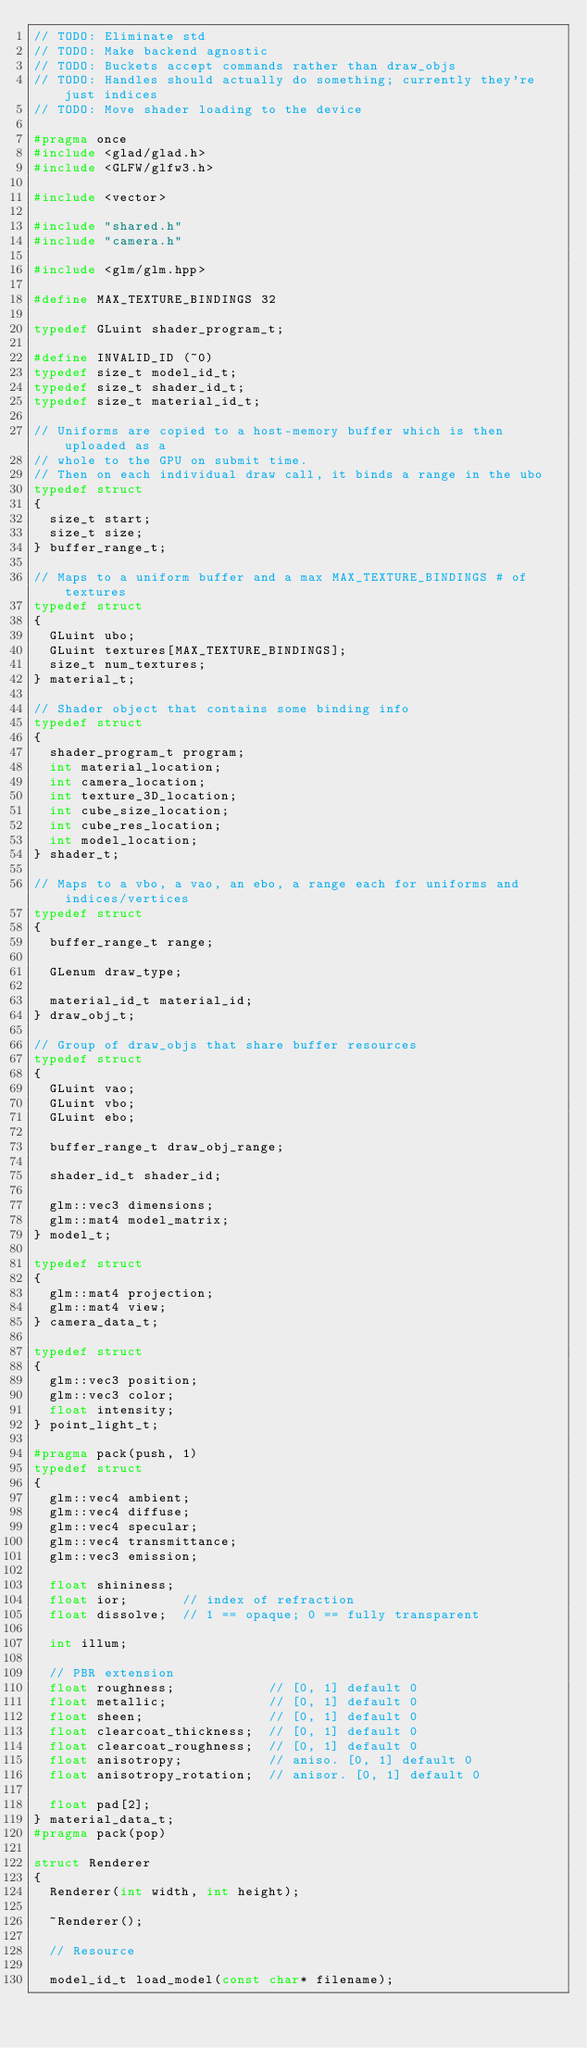Convert code to text. <code><loc_0><loc_0><loc_500><loc_500><_C_>// TODO: Eliminate std
// TODO: Make backend agnostic
// TODO: Buckets accept commands rather than draw_objs
// TODO: Handles should actually do something; currently they're just indices
// TODO: Move shader loading to the device

#pragma once
#include <glad/glad.h>
#include <GLFW/glfw3.h>

#include <vector>

#include "shared.h"
#include "camera.h"

#include <glm/glm.hpp>

#define MAX_TEXTURE_BINDINGS 32

typedef GLuint shader_program_t;

#define INVALID_ID (~0)
typedef size_t model_id_t;
typedef size_t shader_id_t;
typedef size_t material_id_t;

// Uniforms are copied to a host-memory buffer which is then uploaded as a
// whole to the GPU on submit time.
// Then on each individual draw call, it binds a range in the ubo
typedef struct
{
  size_t start;
  size_t size;  
} buffer_range_t;

// Maps to a uniform buffer and a max MAX_TEXTURE_BINDINGS # of textures
typedef struct
{
  GLuint ubo;
  GLuint textures[MAX_TEXTURE_BINDINGS];
  size_t num_textures;
} material_t;

// Shader object that contains some binding info 
typedef struct
{
  shader_program_t program;
  int material_location;
  int camera_location;
  int texture_3D_location;
  int cube_size_location;
  int cube_res_location;
  int model_location;
} shader_t;

// Maps to a vbo, a vao, an ebo, a range each for uniforms and indices/vertices
typedef struct
{
  buffer_range_t range;
  
  GLenum draw_type;
  
  material_id_t material_id;
} draw_obj_t;

// Group of draw_objs that share buffer resources
typedef struct
{
  GLuint vao;
  GLuint vbo;
  GLuint ebo;

  buffer_range_t draw_obj_range;

  shader_id_t shader_id;

  glm::vec3 dimensions;
  glm::mat4 model_matrix;
} model_t;

typedef struct
{
  glm::mat4 projection;
  glm::mat4 view;
} camera_data_t;

typedef struct
{
  glm::vec3 position;
  glm::vec3 color;
  float intensity;
} point_light_t;

#pragma pack(push, 1)
typedef struct 
{
  glm::vec4 ambient;
  glm::vec4 diffuse;
  glm::vec4 specular;
  glm::vec4 transmittance;
  glm::vec3 emission;

  float shininess;
  float ior;       // index of refraction
  float dissolve;  // 1 == opaque; 0 == fully transparent

  int illum;

  // PBR extension
  float roughness;            // [0, 1] default 0
  float metallic;             // [0, 1] default 0
  float sheen;                // [0, 1] default 0
  float clearcoat_thickness;  // [0, 1] default 0
  float clearcoat_roughness;  // [0, 1] default 0
  float anisotropy;           // aniso. [0, 1] default 0
  float anisotropy_rotation;  // anisor. [0, 1] default 0

  float pad[2];
} material_data_t;
#pragma pack(pop)

struct Renderer
{
  Renderer(int width, int height);

  ~Renderer(); 

  // Resource 

  model_id_t load_model(const char* filename);</code> 